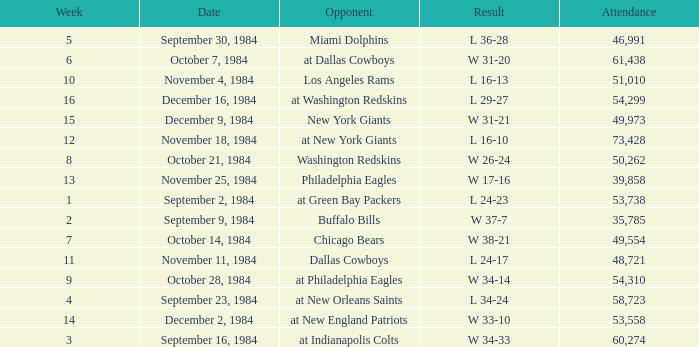What was the result in a week lower than 10 with an opponent of Chicago Bears? W 38-21. 